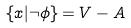Convert formula to latex. <formula><loc_0><loc_0><loc_500><loc_500>\{ x | \neg \phi \} = V - A</formula> 